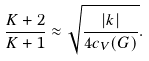Convert formula to latex. <formula><loc_0><loc_0><loc_500><loc_500>\frac { K + 2 } { K + 1 } \approx \sqrt { \frac { | k | } { 4 c _ { V } ( G ) } } .</formula> 